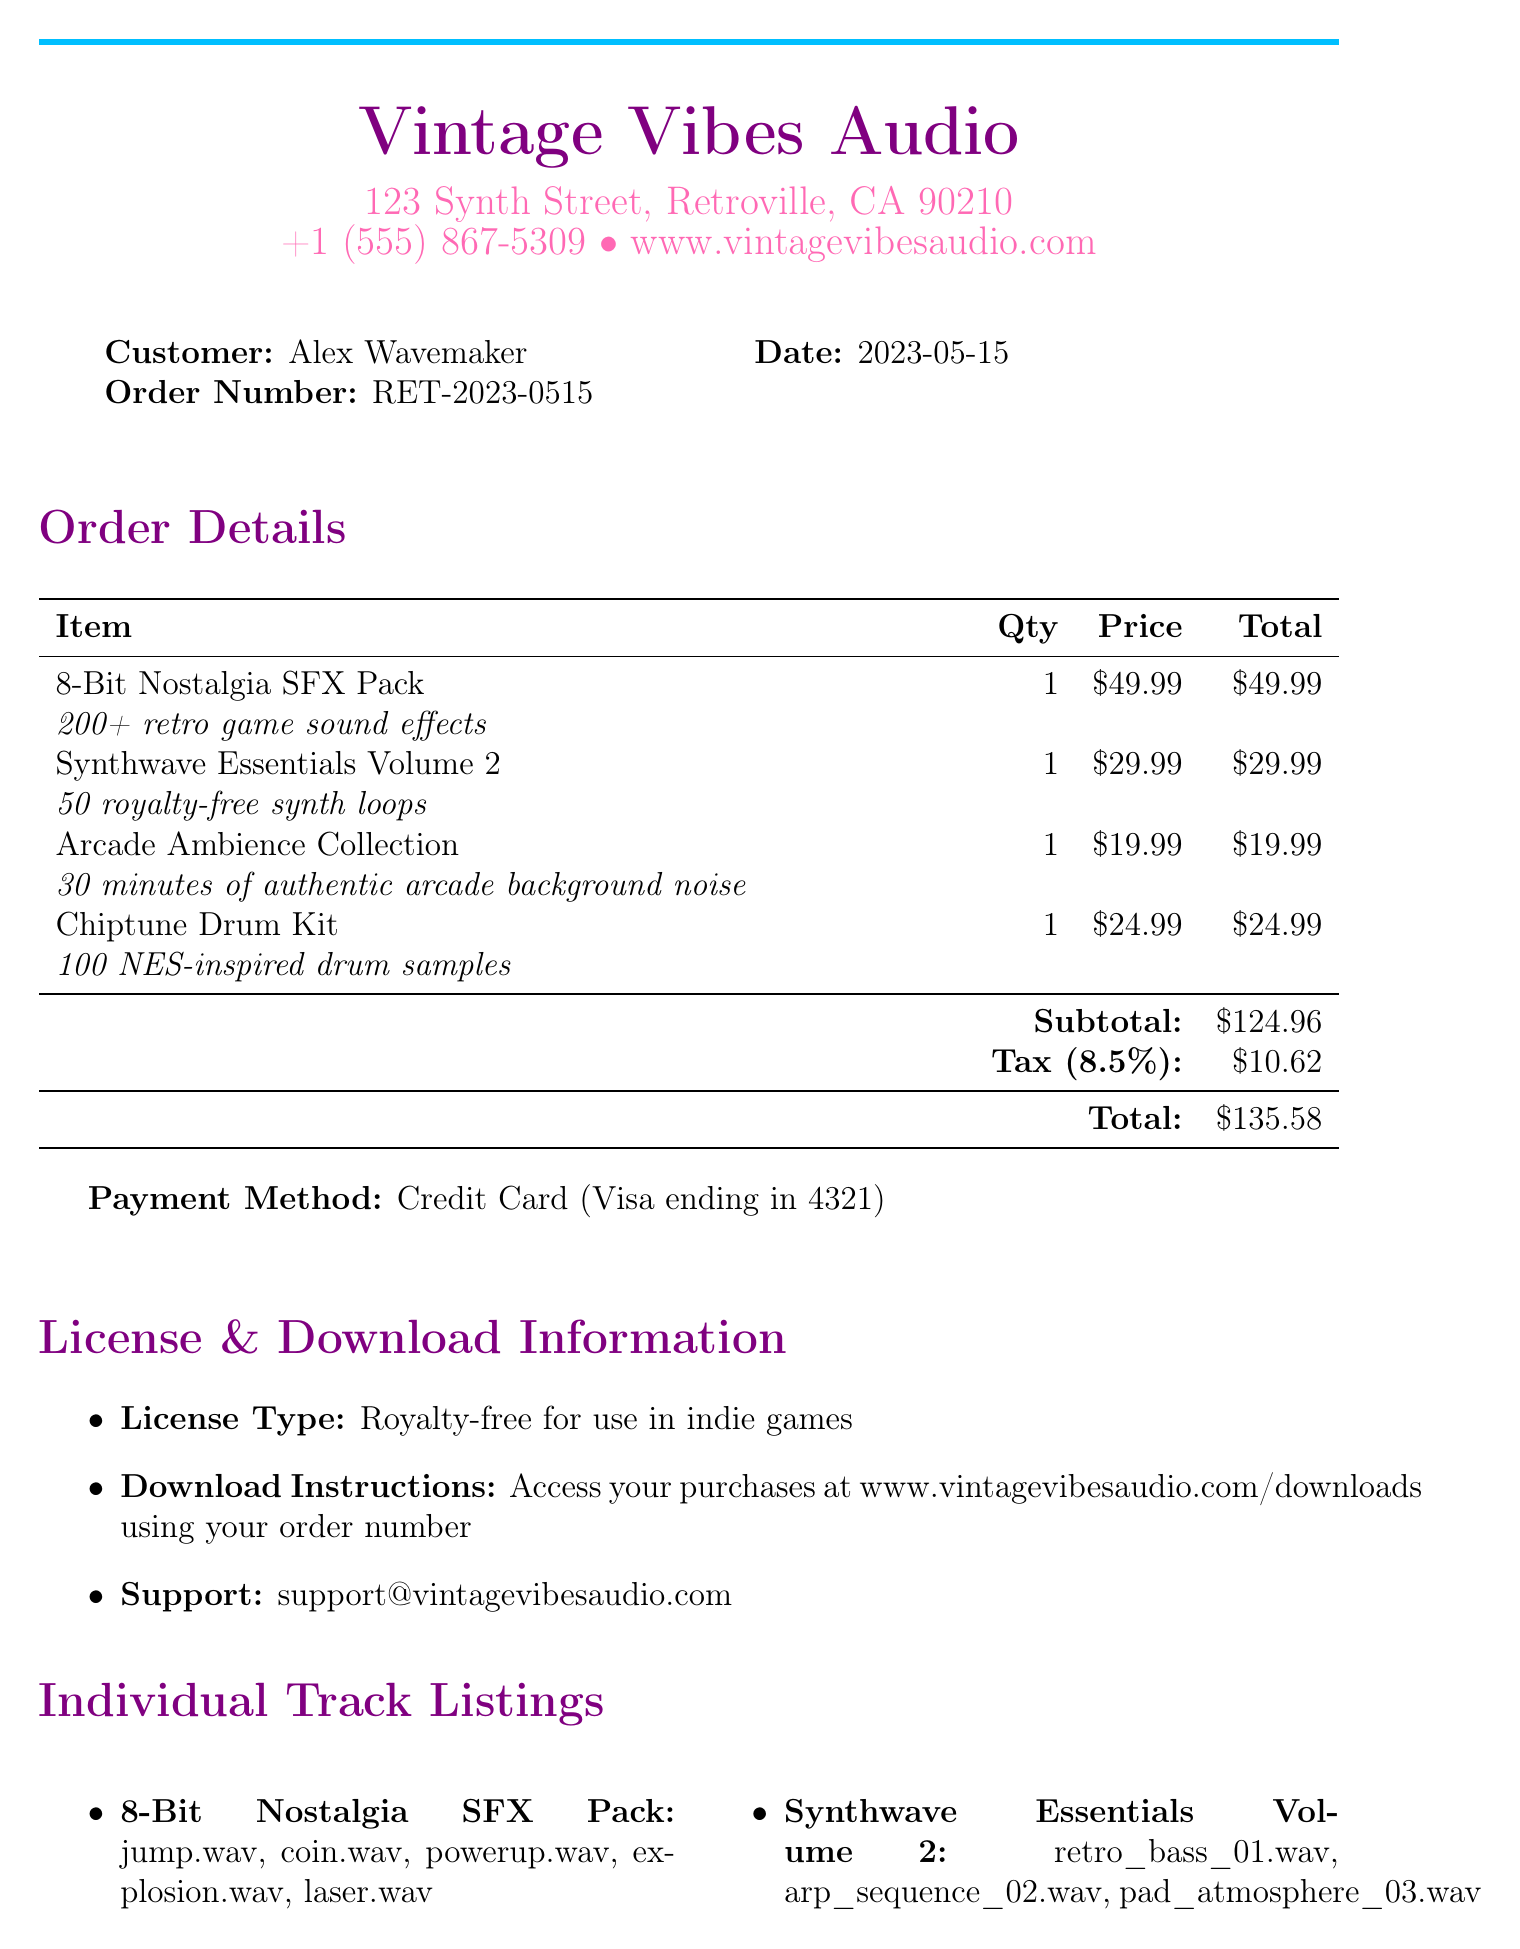What is the company name? The company name appears at the top of the receipt as the business providing the service.
Answer: Vintage Vibes Audio What is the order number? The order number is a unique identifier for the transaction listed in the document.
Answer: RET-2023-0515 What is the total amount paid? The total amount is calculated by adding the subtotal and tax, as shown in the order details.
Answer: 135.58 How many tracks are included in the 8-Bit Nostalgia SFX Pack? The track listing for the 8-Bit Nostalgia SFX Pack shows it contains five sound effects.
Answer: 5 Who is the customer? The customer name is listed in the receipt, indicating who made the purchase.
Answer: Alex Wavemaker What is the tax rate? The tax rate is specified in the order details as a percentage applied to the subtotal.
Answer: 8.5% Which software is compatible? The compatible software section lists specific audio editing programs that work with the product.
Answer: FL Studio What is the license type? The license type defines how the purchased items can be used, which is specified in the document.
Answer: Royalty-free for use in indie games 